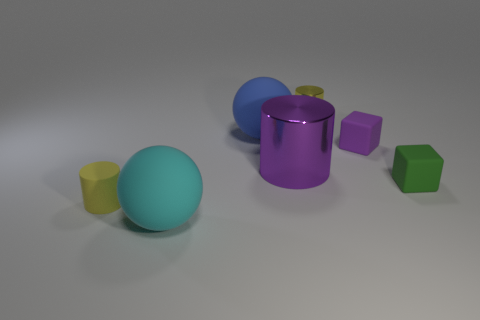Are there any yellow cylinders in front of the big rubber ball behind the cyan ball that is in front of the big shiny object?
Keep it short and to the point. Yes. What is the material of the other purple thing that is the same shape as the tiny shiny thing?
Ensure brevity in your answer.  Metal. There is a tiny yellow cylinder in front of the purple metallic object; how many rubber cubes are left of it?
Ensure brevity in your answer.  0. What size is the yellow thing that is to the left of the big rubber object that is in front of the tiny rubber thing to the left of the small shiny cylinder?
Ensure brevity in your answer.  Small. What is the color of the large sphere that is right of the big object in front of the green block?
Offer a very short reply. Blue. What number of other objects are there of the same material as the large cylinder?
Your answer should be compact. 1. What number of other objects are the same color as the tiny shiny cylinder?
Provide a succinct answer. 1. What material is the purple thing that is to the left of the yellow cylinder that is behind the purple rubber block?
Offer a terse response. Metal. Are any cyan metal cylinders visible?
Your answer should be very brief. No. There is a green thing that is to the right of the purple thing that is on the left side of the yellow shiny cylinder; what size is it?
Offer a very short reply. Small. 